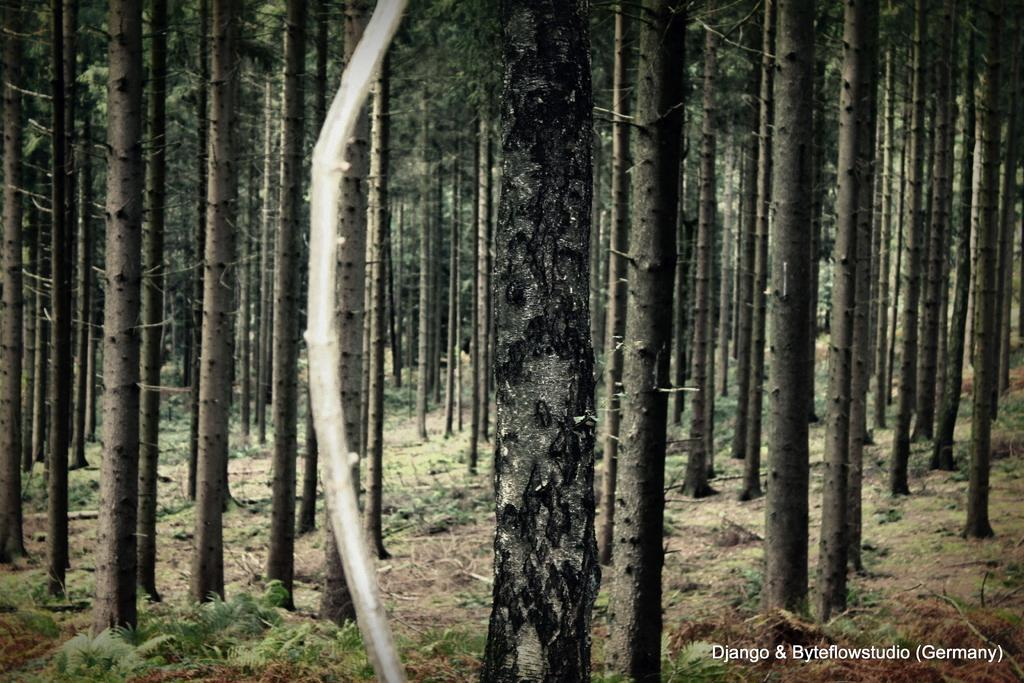What type of vegetation can be seen in the image? There are trees and plants in the image. Where are the plants located in the image? The plants are at the bottom of the image. What is present at the bottom of the image along with the plants? There is mud at the bottom of the image. Is there any text in the image? Yes, there is a text in the bottom right corner of the image. How many apples are hanging from the trees in the image? There are no apples visible in the image; only trees and plants are present. What type of rice can be seen growing in the image? There is no rice present in the image; it features trees and plants. 